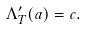Convert formula to latex. <formula><loc_0><loc_0><loc_500><loc_500>\Lambda ^ { \prime } _ { T } ( a ) = c .</formula> 